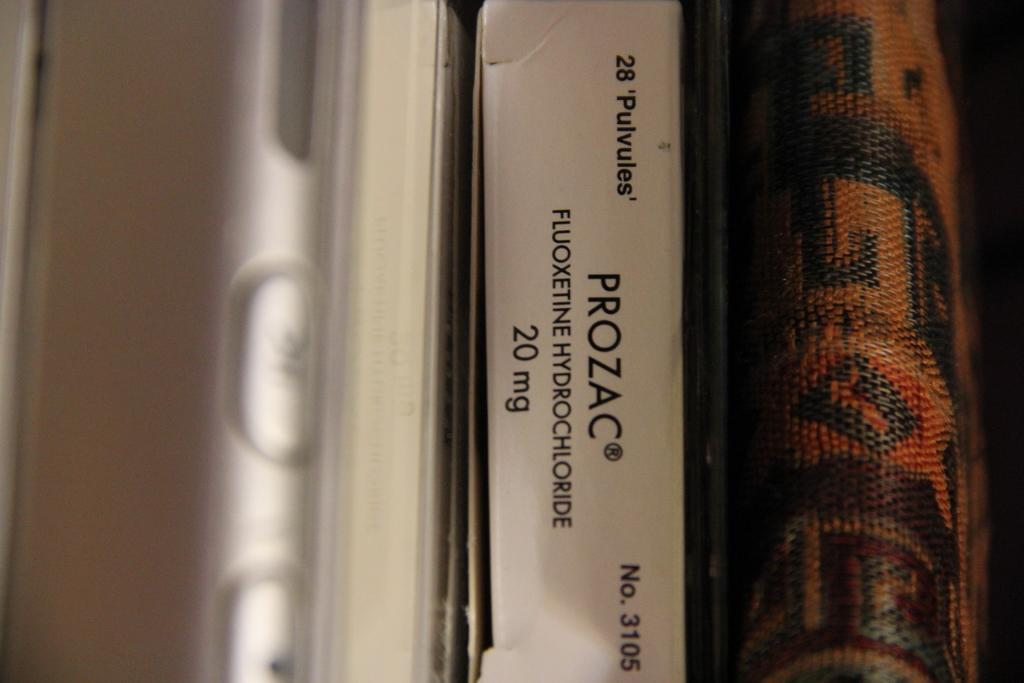Provide a one-sentence caption for the provided image. A row of binders with and a package of 20 mg Prozac. 